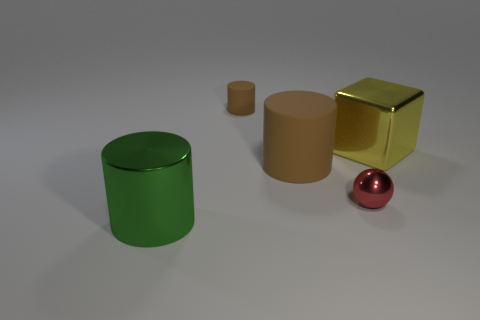There is a small red thing that is made of the same material as the yellow thing; what shape is it?
Make the answer very short. Sphere. What number of rubber objects have the same color as the small cylinder?
Provide a succinct answer. 1. What number of things are tiny red cubes or large yellow metallic cubes?
Provide a short and direct response. 1. What material is the big cylinder behind the cylinder in front of the large brown rubber object made of?
Your answer should be compact. Rubber. Are there any other tiny red balls that have the same material as the tiny red ball?
Provide a succinct answer. No. What shape is the tiny object to the left of the brown thing in front of the shiny thing on the right side of the red ball?
Your answer should be compact. Cylinder. What material is the large yellow object?
Provide a succinct answer. Metal. What is the color of the ball that is made of the same material as the big green thing?
Ensure brevity in your answer.  Red. There is a big matte cylinder that is to the left of the small ball; are there any yellow things in front of it?
Your answer should be very brief. No. How many other things are there of the same shape as the green metal object?
Your answer should be compact. 2. 